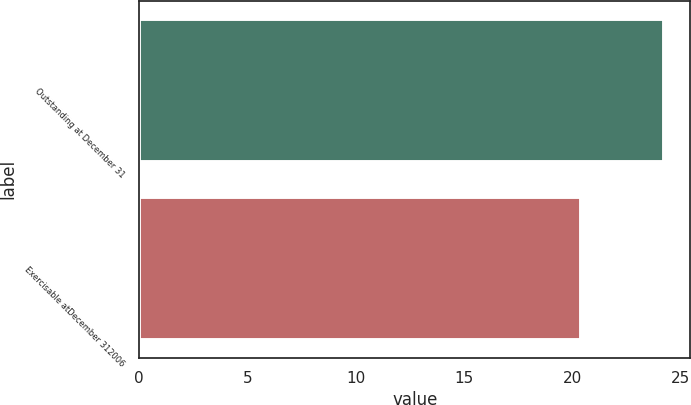Convert chart to OTSL. <chart><loc_0><loc_0><loc_500><loc_500><bar_chart><fcel>Outstanding at December 31<fcel>Exercisable atDecember 312006<nl><fcel>24.24<fcel>20.39<nl></chart> 